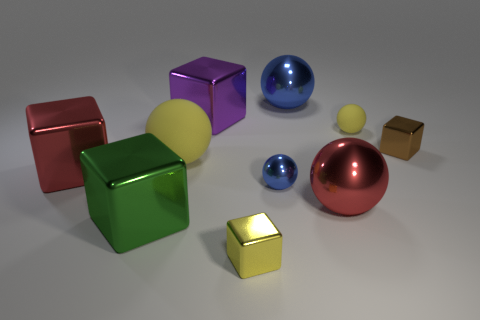Subtract 2 spheres. How many spheres are left? 3 Subtract all red balls. How many balls are left? 4 Subtract all brown metallic blocks. How many blocks are left? 4 Subtract all brown spheres. Subtract all cyan cubes. How many spheres are left? 5 Subtract all red balls. Subtract all large shiny things. How many objects are left? 4 Add 8 tiny blue shiny balls. How many tiny blue shiny balls are left? 9 Add 6 red shiny spheres. How many red shiny spheres exist? 7 Subtract 0 purple balls. How many objects are left? 10 